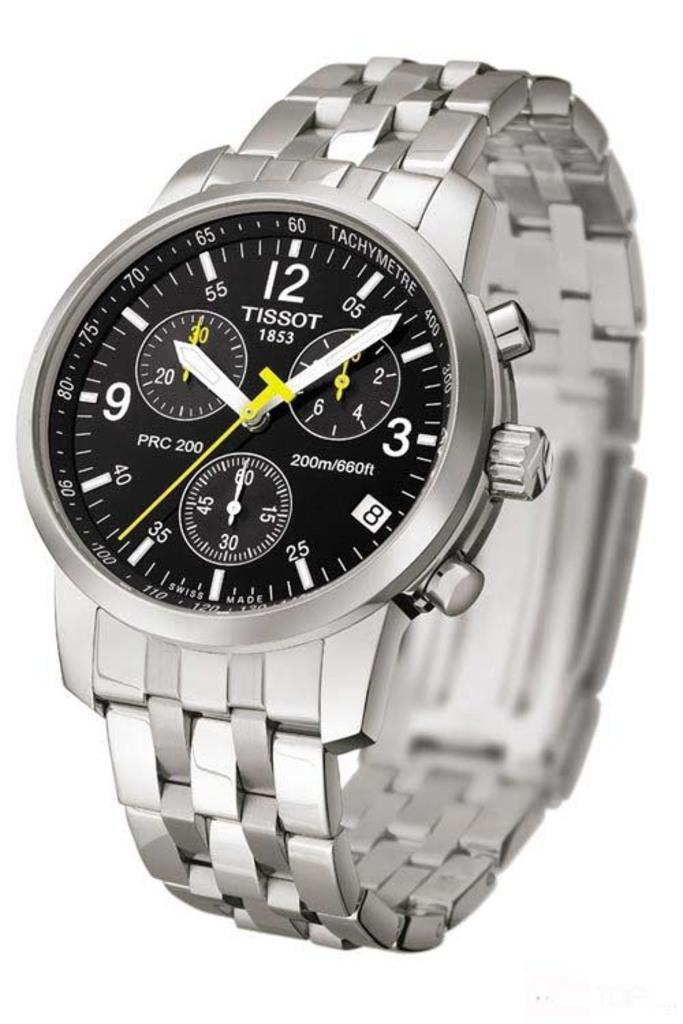<image>
Describe the image concisely. A silver watch with Tissot written on the face. 